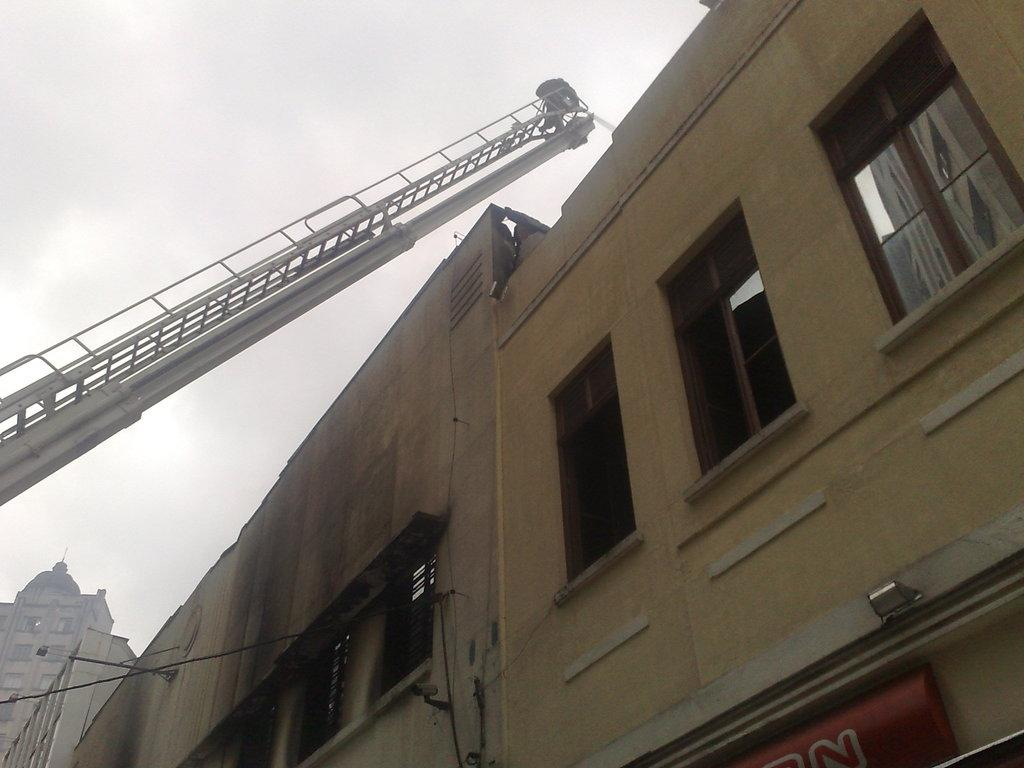What type of structures are present in the image? There are buildings in the image. What feature can be seen on the buildings? The buildings have windows. What construction equipment is visible in the image? There is a crane in the image. What is visible in the background of the image? The sky is visible in the image. What type of yarn is being used to knit the pies in the image? There are no pies or yarn present in the image; it features buildings, windows, a crane, and the sky. What color is the brick used to build the buildings in the image? The provided facts do not mention the color of the brick used to build the buildings in the image. 